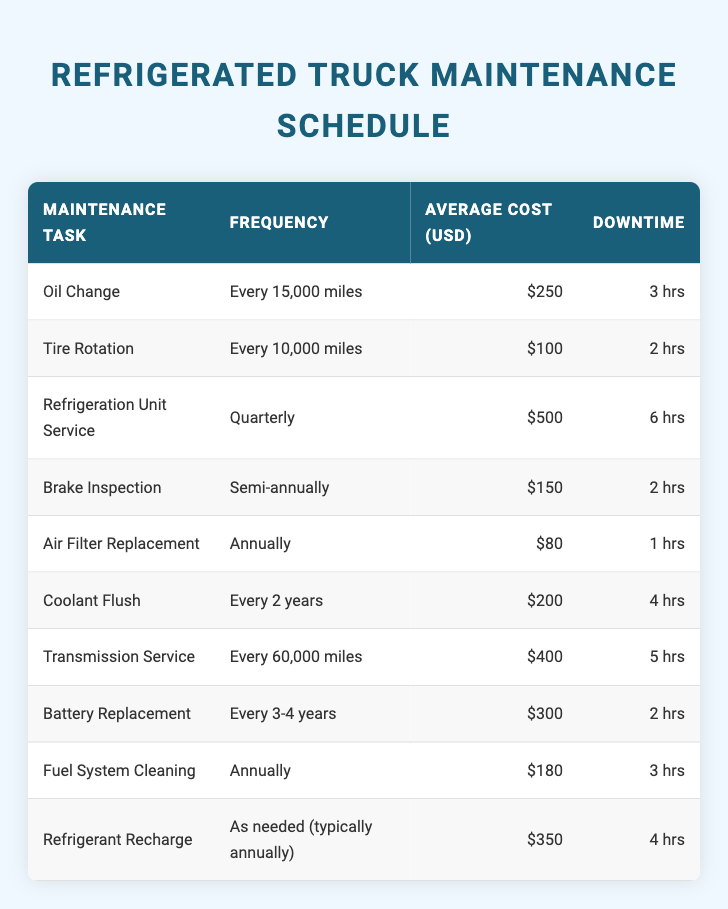What is the average cost of an oil change? The table states that the average cost of an oil change is listed as 250 USD. Therefore, the average cost is simply 250 USD.
Answer: 250 USD How often is the refrigeration unit serviced? The table indicates that the refrigeration unit service is required quarterly. Thus, it occurs four times a year.
Answer: Quarterly What is the total downtime for tire rotation and brake inspection combined? The table shows that the downtime for tire rotation is 2 hours and for brake inspection is 2 hours as well. Adding these gives 2 + 2 = 4 hours of total downtime.
Answer: 4 hours Is the average cost of refrigerant recharge higher than that of a battery replacement? Looking at the table, the average cost for refrigerant recharge is 350 USD and for battery replacement, it is 300 USD. Since 350 is greater than 300, the statement is true.
Answer: Yes What is the downtime difference between a transmission service and a refrigerant recharge? The downtime for a transmission service is 5 hours and for refrigerant recharge, it is 4 hours. To find the difference, subtract: 5 - 4 = 1 hour.
Answer: 1 hour Which maintenance task has the highest average cost? By reviewing the costs in the table, the refrigeration unit service shows the highest average cost at 500 USD compared to all other tasks. Therefore, it is the most expensive.
Answer: Refrigeration Unit Service What is the average downtime for maintenance tasks performed annually? The tasks performed annually are air filter replacement and fuel system cleaning with downtimes of 1 hour and 3 hours, respectively. The average downtime is (1 + 3) / 2 = 2 hours.
Answer: 2 hours Is it necessary to perform brake inspection more frequently than tire rotation? The table describes that brake inspection is semi-annually, while tire rotation is every 10,000 miles. If we consider mileage, tire rotation may happen more often, usually within six months, depending on usage, making the statement false.
Answer: No What is the total average cost for all maintenance tasks listed? To calculate the total average cost, sum all the average costs: 250 + 100 + 500 + 150 + 80 + 200 + 400 + 300 + 180 + 350 = 2210 USD. The total average cost of all tasks is therefore 2210 USD.
Answer: 2210 USD 